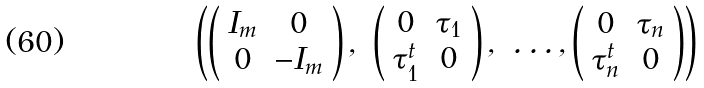Convert formula to latex. <formula><loc_0><loc_0><loc_500><loc_500>\left ( \left ( \begin{array} { c c } I _ { m } & 0 \\ 0 & - I _ { m } \end{array} \right ) , \ \left ( \begin{array} { c c } 0 & { \tau _ { 1 } } \\ { \tau _ { 1 } ^ { t } } & 0 \end{array} \right ) , \ \dots , \left ( \begin{array} { c c } 0 & { \tau _ { n } } \\ { \tau _ { n } ^ { t } } & 0 \end{array} \right ) \right )</formula> 